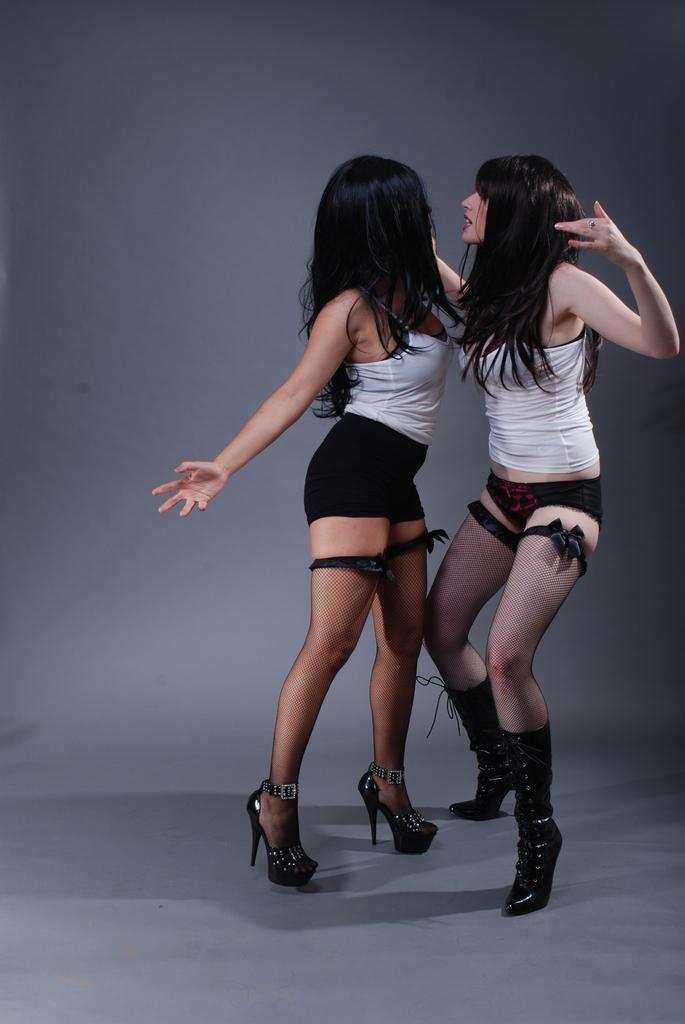Could you give a brief overview of what you see in this image? In this image there are two girls standing opposite to each other. In the background there is a wall. 